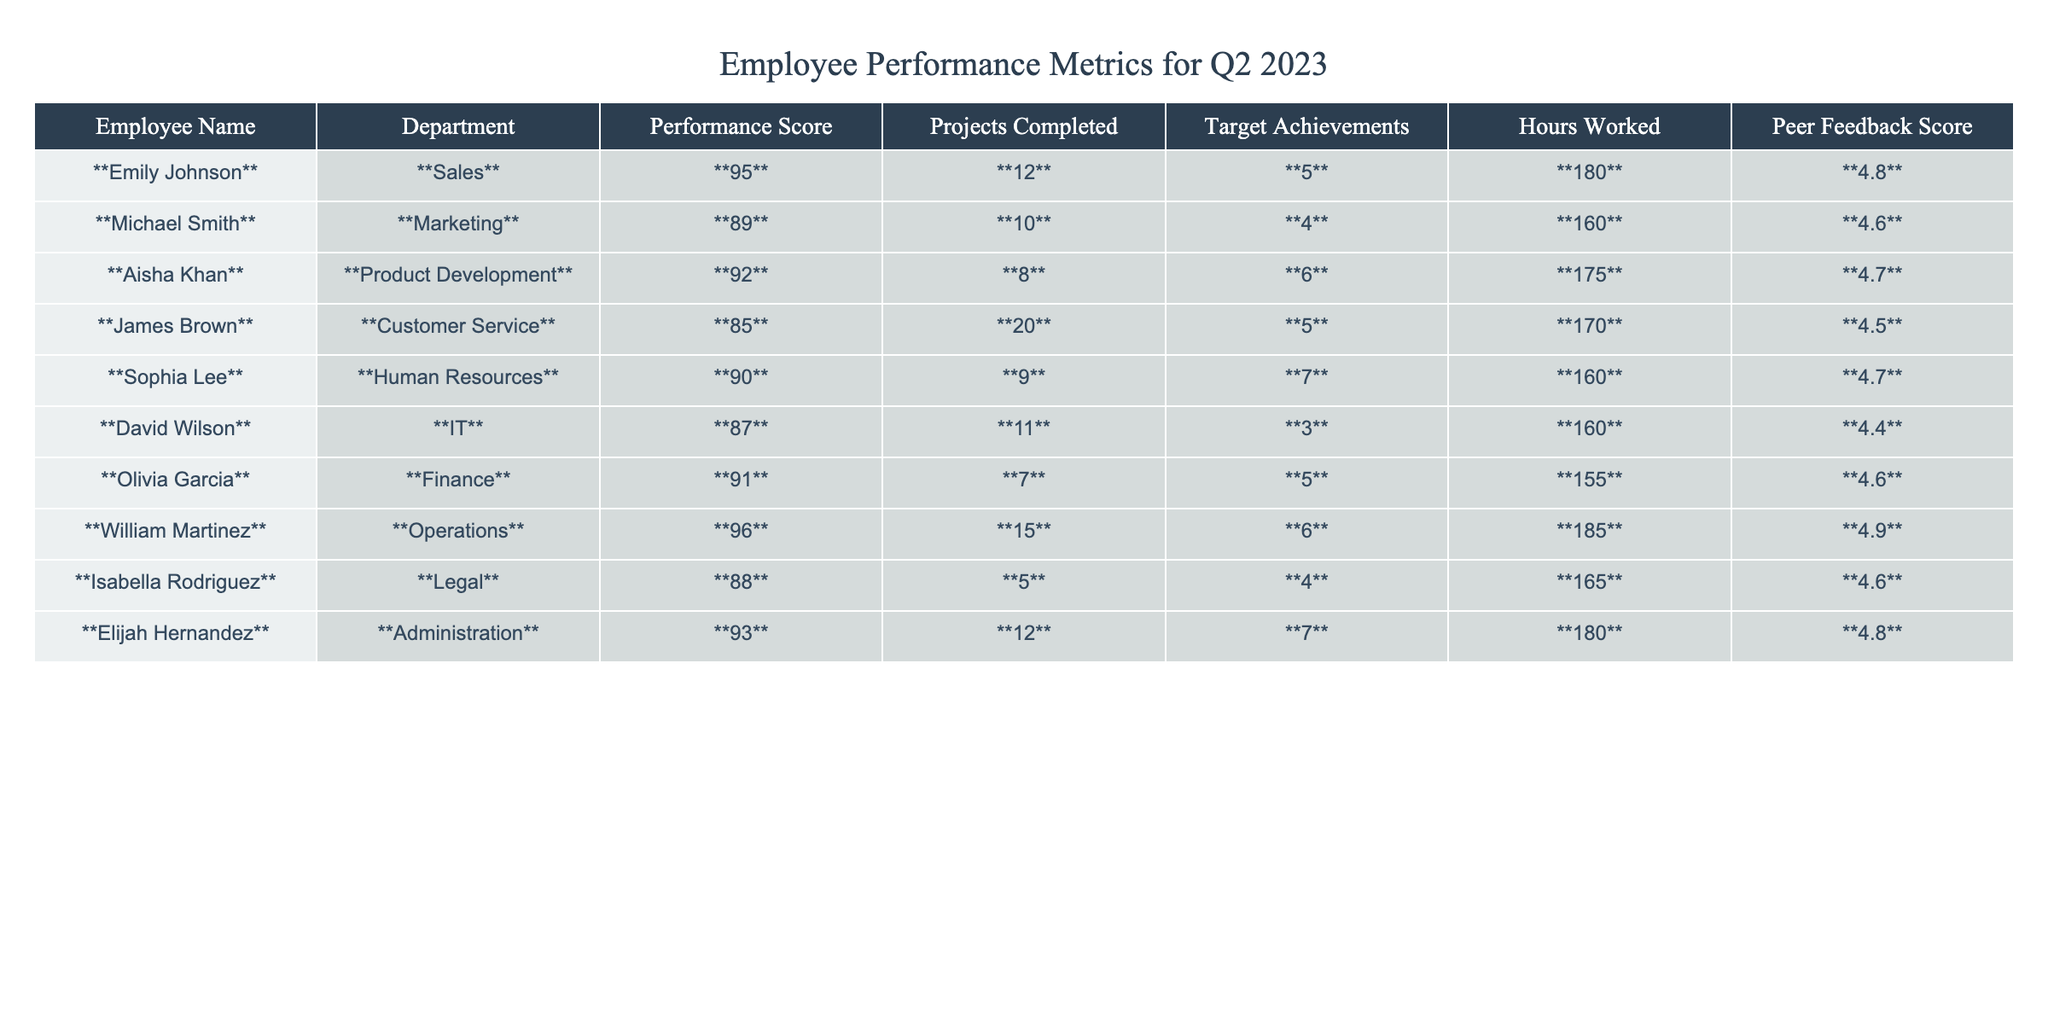What is the performance score of Emily Johnson? According to the table, the performance score listed next to Emily Johnson's name is **95**.
Answer: 95 Who completed the highest number of projects? In the table, William Martinez is noted to have completed the highest number of projects at **15**.
Answer: 15 What is the average performance score of the employees listed? To find the average, add the performance scores (95 + 89 + 92 + 85 + 90 + 87 + 91 + 96 + 88 + 93 = 915) and divide by the number of employees (10). Thus, the average is 915/10 = 91.5.
Answer: 91.5 Did any employee achieve their targets fully? A target achievement of **5** or higher indicates the full achievement of targets, which applies to Emily Johnson, Aisha Khan, Sophia Lee, Olivia Garcia, Elijah Hernandez, and William Martinez. Therefore, the answer is yes.
Answer: Yes How many hours did Michael Smith work compared to the average of all employees? First, Michael Smith worked **160** hours. The average hours worked can be calculated as (180 + 160 + 175 + 170 + 160 + 160 + 155 + 185 + 165 + 180 = 1680) divided by 10, which is **168**. Since 160 hours is below the average, it indicates he worked less.
Answer: Less What is the total number of projects completed by all employees? Summing the projects completed (12 + 10 + 8 + 20 + 9 + 11 + 7 + 15 + 5 + 12 = 119) provides the total number of projects completed by all employees.
Answer: 119 Which department had the employee with the highest peer feedback score, and what was that score? The highest peer feedback score is **4.9** for William Martinez in the Operations department.
Answer: Operations, 4.9 Is there a difference in performance score between James Brown and Elijah Hernandez? James Brown’s performance score is **85**, while Elijah Hernandez’s score is **93**. The difference is 93 - 85 = **8**.
Answer: 8 Which employee worked the most hours, and how many hours did they work? The employee with the most hours worked is William Martinez, who worked **185** hours.
Answer: William Martinez, 185 Are there any employees from the IT department with a performance score above 90? David Wilson, from the IT department, has a performance score of **87**; therefore, there are no employees in IT with a performance score above 90.
Answer: No 